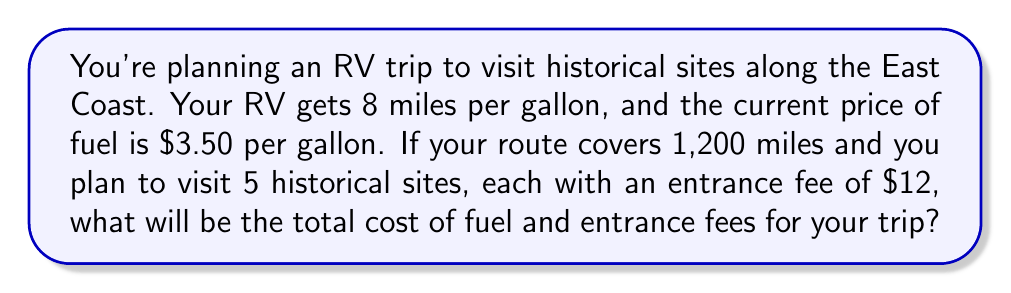Can you solve this math problem? Let's break this problem down into steps:

1. Calculate the amount of fuel needed:
   $$\text{Fuel needed} = \frac{\text{Total distance}}{\text{Miles per gallon}} = \frac{1,200 \text{ miles}}{8 \text{ mpg}} = 150 \text{ gallons}$$

2. Calculate the cost of fuel:
   $$\text{Fuel cost} = \text{Fuel needed} \times \text{Price per gallon} = 150 \text{ gallons} \times \$3.50/\text{gallon} = \$525$$

3. Calculate the total entrance fees:
   $$\text{Entrance fees} = \text{Number of sites} \times \text{Fee per site} = 5 \times \$12 = \$60$$

4. Sum up the total cost:
   $$\text{Total cost} = \text{Fuel cost} + \text{Entrance fees} = \$525 + \$60 = \$585$$

Therefore, the total cost of fuel and entrance fees for your RV trip will be $585.
Answer: $585 